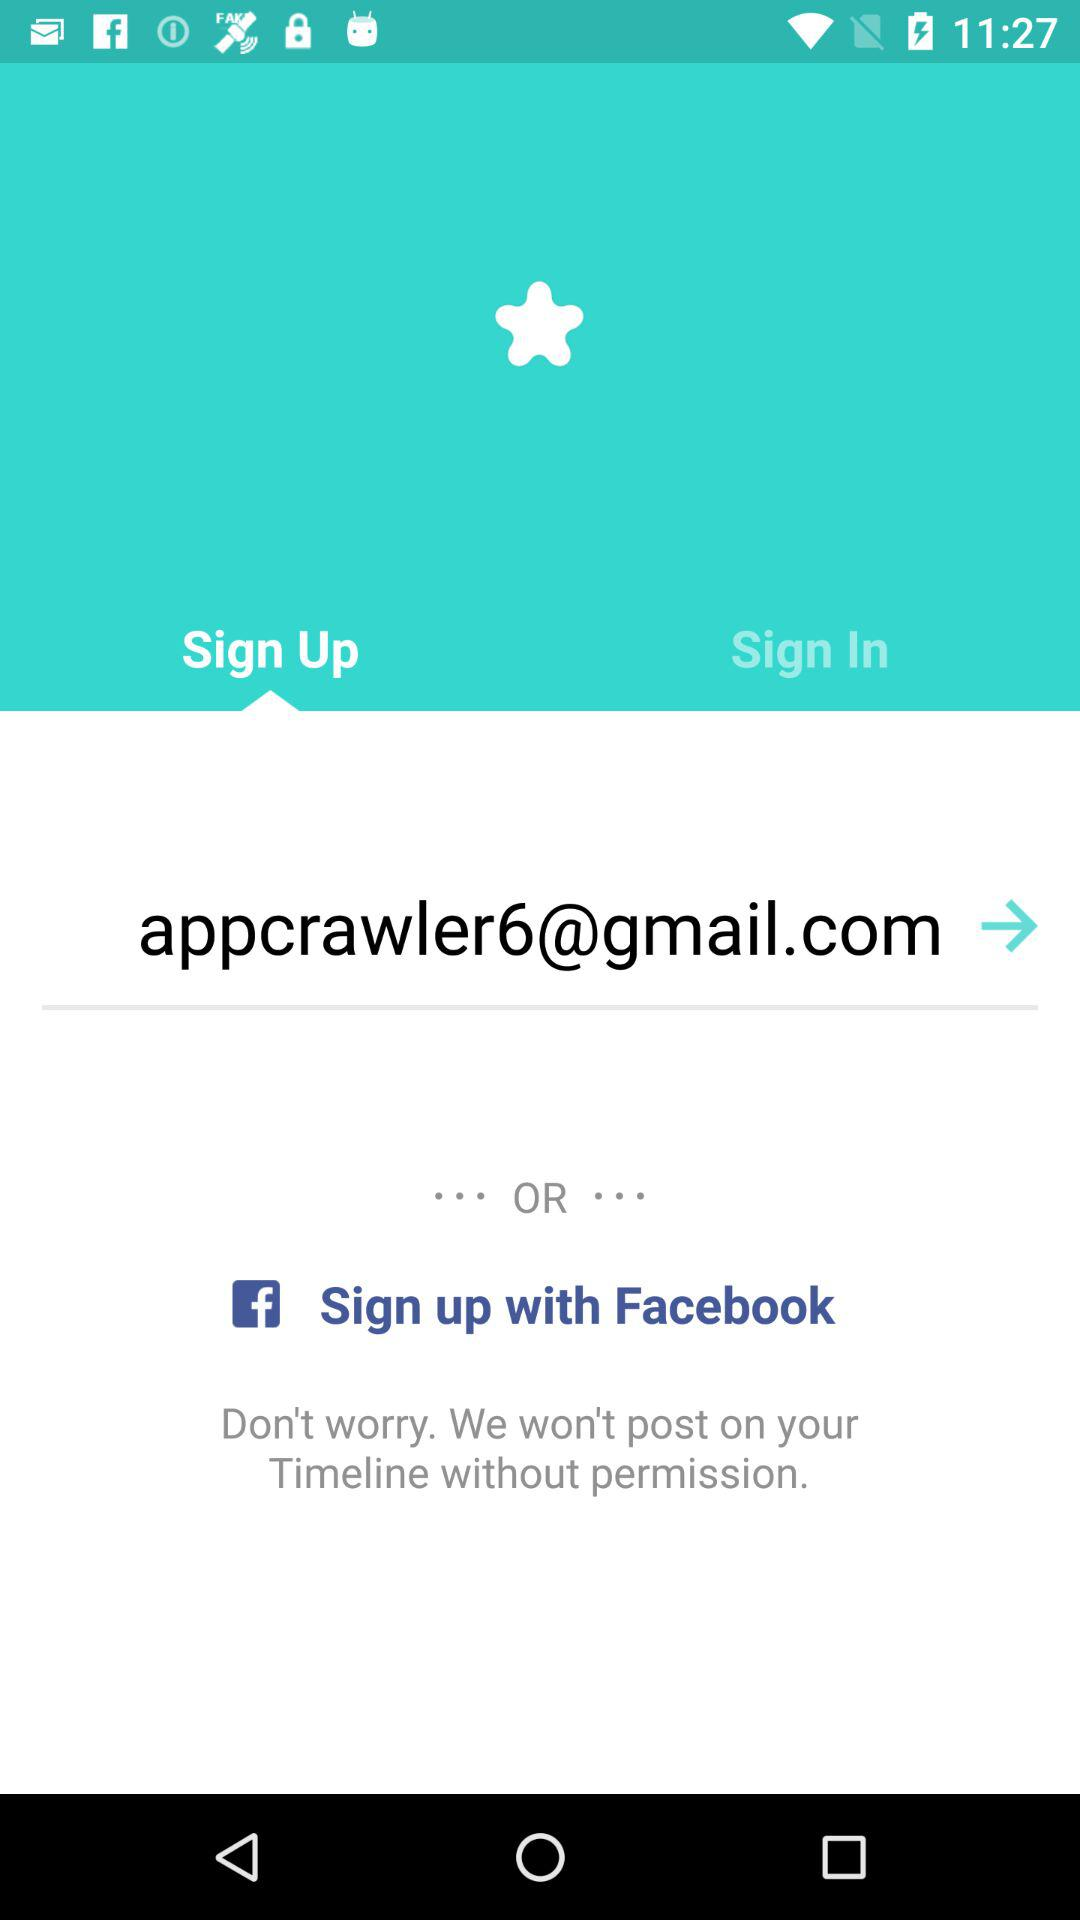Which tab has been selected? The tab that has been selected is "Sign Up". 